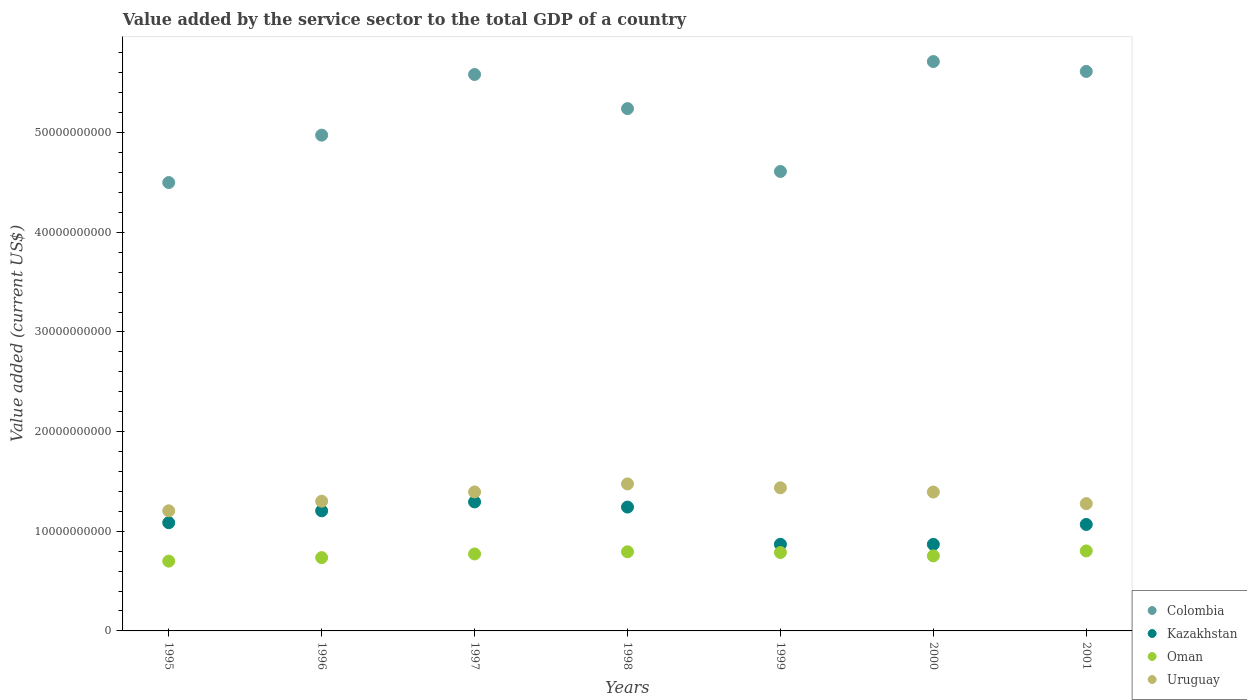Is the number of dotlines equal to the number of legend labels?
Offer a terse response. Yes. What is the value added by the service sector to the total GDP in Oman in 2001?
Offer a terse response. 8.03e+09. Across all years, what is the maximum value added by the service sector to the total GDP in Oman?
Your answer should be very brief. 8.03e+09. Across all years, what is the minimum value added by the service sector to the total GDP in Oman?
Your answer should be compact. 7.00e+09. What is the total value added by the service sector to the total GDP in Uruguay in the graph?
Your answer should be very brief. 9.48e+1. What is the difference between the value added by the service sector to the total GDP in Oman in 2000 and that in 2001?
Give a very brief answer. -4.96e+08. What is the difference between the value added by the service sector to the total GDP in Uruguay in 1995 and the value added by the service sector to the total GDP in Oman in 1999?
Your response must be concise. 4.19e+09. What is the average value added by the service sector to the total GDP in Colombia per year?
Give a very brief answer. 5.18e+1. In the year 1995, what is the difference between the value added by the service sector to the total GDP in Colombia and value added by the service sector to the total GDP in Oman?
Give a very brief answer. 3.80e+1. In how many years, is the value added by the service sector to the total GDP in Uruguay greater than 34000000000 US$?
Your response must be concise. 0. What is the ratio of the value added by the service sector to the total GDP in Oman in 1997 to that in 2001?
Provide a short and direct response. 0.96. What is the difference between the highest and the second highest value added by the service sector to the total GDP in Colombia?
Give a very brief answer. 9.92e+08. What is the difference between the highest and the lowest value added by the service sector to the total GDP in Uruguay?
Give a very brief answer. 2.70e+09. Is it the case that in every year, the sum of the value added by the service sector to the total GDP in Oman and value added by the service sector to the total GDP in Uruguay  is greater than the value added by the service sector to the total GDP in Kazakhstan?
Provide a succinct answer. Yes. Does the value added by the service sector to the total GDP in Kazakhstan monotonically increase over the years?
Ensure brevity in your answer.  No. Is the value added by the service sector to the total GDP in Uruguay strictly greater than the value added by the service sector to the total GDP in Kazakhstan over the years?
Keep it short and to the point. Yes. Is the value added by the service sector to the total GDP in Oman strictly less than the value added by the service sector to the total GDP in Uruguay over the years?
Keep it short and to the point. Yes. What is the difference between two consecutive major ticks on the Y-axis?
Make the answer very short. 1.00e+1. Does the graph contain grids?
Provide a short and direct response. No. Where does the legend appear in the graph?
Provide a short and direct response. Bottom right. How are the legend labels stacked?
Offer a terse response. Vertical. What is the title of the graph?
Make the answer very short. Value added by the service sector to the total GDP of a country. What is the label or title of the Y-axis?
Offer a very short reply. Value added (current US$). What is the Value added (current US$) of Colombia in 1995?
Your answer should be very brief. 4.50e+1. What is the Value added (current US$) of Kazakhstan in 1995?
Provide a short and direct response. 1.09e+1. What is the Value added (current US$) in Oman in 1995?
Your response must be concise. 7.00e+09. What is the Value added (current US$) in Uruguay in 1995?
Your answer should be very brief. 1.21e+1. What is the Value added (current US$) of Colombia in 1996?
Your answer should be very brief. 4.97e+1. What is the Value added (current US$) in Kazakhstan in 1996?
Make the answer very short. 1.21e+1. What is the Value added (current US$) in Oman in 1996?
Provide a succinct answer. 7.35e+09. What is the Value added (current US$) in Uruguay in 1996?
Keep it short and to the point. 1.30e+1. What is the Value added (current US$) in Colombia in 1997?
Offer a very short reply. 5.58e+1. What is the Value added (current US$) of Kazakhstan in 1997?
Keep it short and to the point. 1.29e+1. What is the Value added (current US$) in Oman in 1997?
Make the answer very short. 7.72e+09. What is the Value added (current US$) in Uruguay in 1997?
Keep it short and to the point. 1.39e+1. What is the Value added (current US$) of Colombia in 1998?
Keep it short and to the point. 5.24e+1. What is the Value added (current US$) of Kazakhstan in 1998?
Your answer should be compact. 1.24e+1. What is the Value added (current US$) in Oman in 1998?
Your response must be concise. 7.94e+09. What is the Value added (current US$) of Uruguay in 1998?
Your answer should be very brief. 1.48e+1. What is the Value added (current US$) of Colombia in 1999?
Your response must be concise. 4.61e+1. What is the Value added (current US$) in Kazakhstan in 1999?
Make the answer very short. 8.69e+09. What is the Value added (current US$) of Oman in 1999?
Keep it short and to the point. 7.87e+09. What is the Value added (current US$) of Uruguay in 1999?
Your answer should be compact. 1.44e+1. What is the Value added (current US$) of Colombia in 2000?
Your answer should be compact. 5.71e+1. What is the Value added (current US$) of Kazakhstan in 2000?
Provide a succinct answer. 8.68e+09. What is the Value added (current US$) in Oman in 2000?
Your answer should be compact. 7.53e+09. What is the Value added (current US$) of Uruguay in 2000?
Provide a succinct answer. 1.39e+1. What is the Value added (current US$) in Colombia in 2001?
Give a very brief answer. 5.61e+1. What is the Value added (current US$) in Kazakhstan in 2001?
Your answer should be very brief. 1.07e+1. What is the Value added (current US$) in Oman in 2001?
Make the answer very short. 8.03e+09. What is the Value added (current US$) of Uruguay in 2001?
Offer a terse response. 1.28e+1. Across all years, what is the maximum Value added (current US$) of Colombia?
Ensure brevity in your answer.  5.71e+1. Across all years, what is the maximum Value added (current US$) of Kazakhstan?
Your response must be concise. 1.29e+1. Across all years, what is the maximum Value added (current US$) of Oman?
Offer a very short reply. 8.03e+09. Across all years, what is the maximum Value added (current US$) in Uruguay?
Provide a short and direct response. 1.48e+1. Across all years, what is the minimum Value added (current US$) in Colombia?
Give a very brief answer. 4.50e+1. Across all years, what is the minimum Value added (current US$) of Kazakhstan?
Your answer should be compact. 8.68e+09. Across all years, what is the minimum Value added (current US$) of Oman?
Provide a succinct answer. 7.00e+09. Across all years, what is the minimum Value added (current US$) of Uruguay?
Ensure brevity in your answer.  1.21e+1. What is the total Value added (current US$) in Colombia in the graph?
Provide a succinct answer. 3.62e+11. What is the total Value added (current US$) of Kazakhstan in the graph?
Offer a terse response. 7.63e+1. What is the total Value added (current US$) of Oman in the graph?
Provide a succinct answer. 5.34e+1. What is the total Value added (current US$) of Uruguay in the graph?
Your answer should be very brief. 9.48e+1. What is the difference between the Value added (current US$) of Colombia in 1995 and that in 1996?
Ensure brevity in your answer.  -4.75e+09. What is the difference between the Value added (current US$) of Kazakhstan in 1995 and that in 1996?
Make the answer very short. -1.19e+09. What is the difference between the Value added (current US$) of Oman in 1995 and that in 1996?
Keep it short and to the point. -3.50e+08. What is the difference between the Value added (current US$) in Uruguay in 1995 and that in 1996?
Give a very brief answer. -9.60e+08. What is the difference between the Value added (current US$) in Colombia in 1995 and that in 1997?
Your answer should be compact. -1.08e+1. What is the difference between the Value added (current US$) of Kazakhstan in 1995 and that in 1997?
Provide a succinct answer. -2.08e+09. What is the difference between the Value added (current US$) in Oman in 1995 and that in 1997?
Provide a short and direct response. -7.19e+08. What is the difference between the Value added (current US$) of Uruguay in 1995 and that in 1997?
Give a very brief answer. -1.89e+09. What is the difference between the Value added (current US$) of Colombia in 1995 and that in 1998?
Provide a succinct answer. -7.42e+09. What is the difference between the Value added (current US$) in Kazakhstan in 1995 and that in 1998?
Keep it short and to the point. -1.57e+09. What is the difference between the Value added (current US$) of Oman in 1995 and that in 1998?
Your answer should be compact. -9.37e+08. What is the difference between the Value added (current US$) in Uruguay in 1995 and that in 1998?
Your answer should be very brief. -2.70e+09. What is the difference between the Value added (current US$) of Colombia in 1995 and that in 1999?
Give a very brief answer. -1.11e+09. What is the difference between the Value added (current US$) in Kazakhstan in 1995 and that in 1999?
Your response must be concise. 2.17e+09. What is the difference between the Value added (current US$) in Oman in 1995 and that in 1999?
Your answer should be compact. -8.64e+08. What is the difference between the Value added (current US$) in Uruguay in 1995 and that in 1999?
Make the answer very short. -2.31e+09. What is the difference between the Value added (current US$) in Colombia in 1995 and that in 2000?
Make the answer very short. -1.21e+1. What is the difference between the Value added (current US$) of Kazakhstan in 1995 and that in 2000?
Make the answer very short. 2.18e+09. What is the difference between the Value added (current US$) in Oman in 1995 and that in 2000?
Your answer should be compact. -5.27e+08. What is the difference between the Value added (current US$) in Uruguay in 1995 and that in 2000?
Your answer should be very brief. -1.88e+09. What is the difference between the Value added (current US$) of Colombia in 1995 and that in 2001?
Give a very brief answer. -1.11e+1. What is the difference between the Value added (current US$) of Kazakhstan in 1995 and that in 2001?
Provide a short and direct response. 1.77e+08. What is the difference between the Value added (current US$) of Oman in 1995 and that in 2001?
Provide a succinct answer. -1.02e+09. What is the difference between the Value added (current US$) of Uruguay in 1995 and that in 2001?
Make the answer very short. -7.18e+08. What is the difference between the Value added (current US$) in Colombia in 1996 and that in 1997?
Give a very brief answer. -6.09e+09. What is the difference between the Value added (current US$) in Kazakhstan in 1996 and that in 1997?
Provide a short and direct response. -8.92e+08. What is the difference between the Value added (current US$) in Oman in 1996 and that in 1997?
Offer a very short reply. -3.69e+08. What is the difference between the Value added (current US$) of Uruguay in 1996 and that in 1997?
Your response must be concise. -9.29e+08. What is the difference between the Value added (current US$) of Colombia in 1996 and that in 1998?
Your answer should be very brief. -2.66e+09. What is the difference between the Value added (current US$) of Kazakhstan in 1996 and that in 1998?
Make the answer very short. -3.76e+08. What is the difference between the Value added (current US$) in Oman in 1996 and that in 1998?
Offer a very short reply. -5.87e+08. What is the difference between the Value added (current US$) of Uruguay in 1996 and that in 1998?
Provide a short and direct response. -1.74e+09. What is the difference between the Value added (current US$) in Colombia in 1996 and that in 1999?
Your response must be concise. 3.64e+09. What is the difference between the Value added (current US$) in Kazakhstan in 1996 and that in 1999?
Give a very brief answer. 3.36e+09. What is the difference between the Value added (current US$) of Oman in 1996 and that in 1999?
Make the answer very short. -5.14e+08. What is the difference between the Value added (current US$) of Uruguay in 1996 and that in 1999?
Ensure brevity in your answer.  -1.35e+09. What is the difference between the Value added (current US$) of Colombia in 1996 and that in 2000?
Your answer should be very brief. -7.39e+09. What is the difference between the Value added (current US$) in Kazakhstan in 1996 and that in 2000?
Give a very brief answer. 3.37e+09. What is the difference between the Value added (current US$) of Oman in 1996 and that in 2000?
Ensure brevity in your answer.  -1.77e+08. What is the difference between the Value added (current US$) of Uruguay in 1996 and that in 2000?
Your response must be concise. -9.21e+08. What is the difference between the Value added (current US$) in Colombia in 1996 and that in 2001?
Your response must be concise. -6.39e+09. What is the difference between the Value added (current US$) of Kazakhstan in 1996 and that in 2001?
Provide a short and direct response. 1.37e+09. What is the difference between the Value added (current US$) in Oman in 1996 and that in 2001?
Give a very brief answer. -6.74e+08. What is the difference between the Value added (current US$) in Uruguay in 1996 and that in 2001?
Your answer should be compact. 2.42e+08. What is the difference between the Value added (current US$) in Colombia in 1997 and that in 1998?
Provide a succinct answer. 3.43e+09. What is the difference between the Value added (current US$) of Kazakhstan in 1997 and that in 1998?
Offer a terse response. 5.16e+08. What is the difference between the Value added (current US$) of Oman in 1997 and that in 1998?
Provide a short and direct response. -2.18e+08. What is the difference between the Value added (current US$) of Uruguay in 1997 and that in 1998?
Give a very brief answer. -8.08e+08. What is the difference between the Value added (current US$) in Colombia in 1997 and that in 1999?
Provide a succinct answer. 9.73e+09. What is the difference between the Value added (current US$) in Kazakhstan in 1997 and that in 1999?
Keep it short and to the point. 4.25e+09. What is the difference between the Value added (current US$) in Oman in 1997 and that in 1999?
Provide a succinct answer. -1.46e+08. What is the difference between the Value added (current US$) of Uruguay in 1997 and that in 1999?
Provide a succinct answer. -4.17e+08. What is the difference between the Value added (current US$) in Colombia in 1997 and that in 2000?
Provide a short and direct response. -1.30e+09. What is the difference between the Value added (current US$) in Kazakhstan in 1997 and that in 2000?
Your answer should be compact. 4.26e+09. What is the difference between the Value added (current US$) in Oman in 1997 and that in 2000?
Make the answer very short. 1.92e+08. What is the difference between the Value added (current US$) in Uruguay in 1997 and that in 2000?
Your answer should be very brief. 8.73e+06. What is the difference between the Value added (current US$) in Colombia in 1997 and that in 2001?
Offer a very short reply. -3.06e+08. What is the difference between the Value added (current US$) in Kazakhstan in 1997 and that in 2001?
Your answer should be compact. 2.26e+09. What is the difference between the Value added (current US$) in Oman in 1997 and that in 2001?
Your response must be concise. -3.05e+08. What is the difference between the Value added (current US$) of Uruguay in 1997 and that in 2001?
Offer a terse response. 1.17e+09. What is the difference between the Value added (current US$) of Colombia in 1998 and that in 1999?
Offer a terse response. 6.31e+09. What is the difference between the Value added (current US$) in Kazakhstan in 1998 and that in 1999?
Offer a terse response. 3.74e+09. What is the difference between the Value added (current US$) of Oman in 1998 and that in 1999?
Give a very brief answer. 7.28e+07. What is the difference between the Value added (current US$) of Uruguay in 1998 and that in 1999?
Your answer should be compact. 3.91e+08. What is the difference between the Value added (current US$) in Colombia in 1998 and that in 2000?
Provide a short and direct response. -4.72e+09. What is the difference between the Value added (current US$) in Kazakhstan in 1998 and that in 2000?
Ensure brevity in your answer.  3.74e+09. What is the difference between the Value added (current US$) in Oman in 1998 and that in 2000?
Offer a very short reply. 4.10e+08. What is the difference between the Value added (current US$) in Uruguay in 1998 and that in 2000?
Give a very brief answer. 8.17e+08. What is the difference between the Value added (current US$) of Colombia in 1998 and that in 2001?
Your answer should be compact. -3.73e+09. What is the difference between the Value added (current US$) of Kazakhstan in 1998 and that in 2001?
Keep it short and to the point. 1.74e+09. What is the difference between the Value added (current US$) of Oman in 1998 and that in 2001?
Provide a short and direct response. -8.65e+07. What is the difference between the Value added (current US$) of Uruguay in 1998 and that in 2001?
Make the answer very short. 1.98e+09. What is the difference between the Value added (current US$) of Colombia in 1999 and that in 2000?
Keep it short and to the point. -1.10e+1. What is the difference between the Value added (current US$) of Kazakhstan in 1999 and that in 2000?
Your answer should be very brief. 7.84e+06. What is the difference between the Value added (current US$) of Oman in 1999 and that in 2000?
Make the answer very short. 3.37e+08. What is the difference between the Value added (current US$) in Uruguay in 1999 and that in 2000?
Ensure brevity in your answer.  4.26e+08. What is the difference between the Value added (current US$) of Colombia in 1999 and that in 2001?
Ensure brevity in your answer.  -1.00e+1. What is the difference between the Value added (current US$) of Kazakhstan in 1999 and that in 2001?
Ensure brevity in your answer.  -1.99e+09. What is the difference between the Value added (current US$) of Oman in 1999 and that in 2001?
Offer a terse response. -1.59e+08. What is the difference between the Value added (current US$) of Uruguay in 1999 and that in 2001?
Give a very brief answer. 1.59e+09. What is the difference between the Value added (current US$) in Colombia in 2000 and that in 2001?
Make the answer very short. 9.92e+08. What is the difference between the Value added (current US$) of Kazakhstan in 2000 and that in 2001?
Give a very brief answer. -2.00e+09. What is the difference between the Value added (current US$) of Oman in 2000 and that in 2001?
Keep it short and to the point. -4.96e+08. What is the difference between the Value added (current US$) of Uruguay in 2000 and that in 2001?
Offer a terse response. 1.16e+09. What is the difference between the Value added (current US$) of Colombia in 1995 and the Value added (current US$) of Kazakhstan in 1996?
Give a very brief answer. 3.29e+1. What is the difference between the Value added (current US$) of Colombia in 1995 and the Value added (current US$) of Oman in 1996?
Provide a succinct answer. 3.76e+1. What is the difference between the Value added (current US$) in Colombia in 1995 and the Value added (current US$) in Uruguay in 1996?
Make the answer very short. 3.20e+1. What is the difference between the Value added (current US$) in Kazakhstan in 1995 and the Value added (current US$) in Oman in 1996?
Your response must be concise. 3.51e+09. What is the difference between the Value added (current US$) in Kazakhstan in 1995 and the Value added (current US$) in Uruguay in 1996?
Your response must be concise. -2.15e+09. What is the difference between the Value added (current US$) in Oman in 1995 and the Value added (current US$) in Uruguay in 1996?
Provide a short and direct response. -6.01e+09. What is the difference between the Value added (current US$) of Colombia in 1995 and the Value added (current US$) of Kazakhstan in 1997?
Make the answer very short. 3.20e+1. What is the difference between the Value added (current US$) in Colombia in 1995 and the Value added (current US$) in Oman in 1997?
Your answer should be very brief. 3.73e+1. What is the difference between the Value added (current US$) in Colombia in 1995 and the Value added (current US$) in Uruguay in 1997?
Provide a succinct answer. 3.10e+1. What is the difference between the Value added (current US$) in Kazakhstan in 1995 and the Value added (current US$) in Oman in 1997?
Keep it short and to the point. 3.14e+09. What is the difference between the Value added (current US$) in Kazakhstan in 1995 and the Value added (current US$) in Uruguay in 1997?
Give a very brief answer. -3.08e+09. What is the difference between the Value added (current US$) of Oman in 1995 and the Value added (current US$) of Uruguay in 1997?
Your response must be concise. -6.94e+09. What is the difference between the Value added (current US$) in Colombia in 1995 and the Value added (current US$) in Kazakhstan in 1998?
Your answer should be very brief. 3.26e+1. What is the difference between the Value added (current US$) in Colombia in 1995 and the Value added (current US$) in Oman in 1998?
Make the answer very short. 3.70e+1. What is the difference between the Value added (current US$) in Colombia in 1995 and the Value added (current US$) in Uruguay in 1998?
Ensure brevity in your answer.  3.02e+1. What is the difference between the Value added (current US$) in Kazakhstan in 1995 and the Value added (current US$) in Oman in 1998?
Offer a terse response. 2.92e+09. What is the difference between the Value added (current US$) in Kazakhstan in 1995 and the Value added (current US$) in Uruguay in 1998?
Your response must be concise. -3.89e+09. What is the difference between the Value added (current US$) in Oman in 1995 and the Value added (current US$) in Uruguay in 1998?
Provide a short and direct response. -7.75e+09. What is the difference between the Value added (current US$) of Colombia in 1995 and the Value added (current US$) of Kazakhstan in 1999?
Give a very brief answer. 3.63e+1. What is the difference between the Value added (current US$) in Colombia in 1995 and the Value added (current US$) in Oman in 1999?
Provide a succinct answer. 3.71e+1. What is the difference between the Value added (current US$) in Colombia in 1995 and the Value added (current US$) in Uruguay in 1999?
Make the answer very short. 3.06e+1. What is the difference between the Value added (current US$) in Kazakhstan in 1995 and the Value added (current US$) in Oman in 1999?
Keep it short and to the point. 2.99e+09. What is the difference between the Value added (current US$) of Kazakhstan in 1995 and the Value added (current US$) of Uruguay in 1999?
Provide a succinct answer. -3.50e+09. What is the difference between the Value added (current US$) in Oman in 1995 and the Value added (current US$) in Uruguay in 1999?
Give a very brief answer. -7.36e+09. What is the difference between the Value added (current US$) of Colombia in 1995 and the Value added (current US$) of Kazakhstan in 2000?
Your answer should be very brief. 3.63e+1. What is the difference between the Value added (current US$) in Colombia in 1995 and the Value added (current US$) in Oman in 2000?
Make the answer very short. 3.75e+1. What is the difference between the Value added (current US$) in Colombia in 1995 and the Value added (current US$) in Uruguay in 2000?
Provide a succinct answer. 3.11e+1. What is the difference between the Value added (current US$) in Kazakhstan in 1995 and the Value added (current US$) in Oman in 2000?
Provide a succinct answer. 3.33e+09. What is the difference between the Value added (current US$) of Kazakhstan in 1995 and the Value added (current US$) of Uruguay in 2000?
Your answer should be very brief. -3.08e+09. What is the difference between the Value added (current US$) in Oman in 1995 and the Value added (current US$) in Uruguay in 2000?
Your answer should be very brief. -6.93e+09. What is the difference between the Value added (current US$) of Colombia in 1995 and the Value added (current US$) of Kazakhstan in 2001?
Your answer should be compact. 3.43e+1. What is the difference between the Value added (current US$) of Colombia in 1995 and the Value added (current US$) of Oman in 2001?
Give a very brief answer. 3.70e+1. What is the difference between the Value added (current US$) in Colombia in 1995 and the Value added (current US$) in Uruguay in 2001?
Offer a very short reply. 3.22e+1. What is the difference between the Value added (current US$) in Kazakhstan in 1995 and the Value added (current US$) in Oman in 2001?
Offer a terse response. 2.83e+09. What is the difference between the Value added (current US$) in Kazakhstan in 1995 and the Value added (current US$) in Uruguay in 2001?
Make the answer very short. -1.91e+09. What is the difference between the Value added (current US$) in Oman in 1995 and the Value added (current US$) in Uruguay in 2001?
Provide a succinct answer. -5.77e+09. What is the difference between the Value added (current US$) of Colombia in 1996 and the Value added (current US$) of Kazakhstan in 1997?
Your response must be concise. 3.68e+1. What is the difference between the Value added (current US$) in Colombia in 1996 and the Value added (current US$) in Oman in 1997?
Keep it short and to the point. 4.20e+1. What is the difference between the Value added (current US$) of Colombia in 1996 and the Value added (current US$) of Uruguay in 1997?
Offer a very short reply. 3.58e+1. What is the difference between the Value added (current US$) of Kazakhstan in 1996 and the Value added (current US$) of Oman in 1997?
Offer a terse response. 4.33e+09. What is the difference between the Value added (current US$) in Kazakhstan in 1996 and the Value added (current US$) in Uruguay in 1997?
Keep it short and to the point. -1.89e+09. What is the difference between the Value added (current US$) in Oman in 1996 and the Value added (current US$) in Uruguay in 1997?
Your response must be concise. -6.59e+09. What is the difference between the Value added (current US$) of Colombia in 1996 and the Value added (current US$) of Kazakhstan in 1998?
Your answer should be compact. 3.73e+1. What is the difference between the Value added (current US$) of Colombia in 1996 and the Value added (current US$) of Oman in 1998?
Your answer should be compact. 4.18e+1. What is the difference between the Value added (current US$) in Colombia in 1996 and the Value added (current US$) in Uruguay in 1998?
Give a very brief answer. 3.50e+1. What is the difference between the Value added (current US$) of Kazakhstan in 1996 and the Value added (current US$) of Oman in 1998?
Provide a succinct answer. 4.11e+09. What is the difference between the Value added (current US$) in Kazakhstan in 1996 and the Value added (current US$) in Uruguay in 1998?
Provide a short and direct response. -2.70e+09. What is the difference between the Value added (current US$) in Oman in 1996 and the Value added (current US$) in Uruguay in 1998?
Make the answer very short. -7.40e+09. What is the difference between the Value added (current US$) in Colombia in 1996 and the Value added (current US$) in Kazakhstan in 1999?
Your answer should be compact. 4.11e+1. What is the difference between the Value added (current US$) in Colombia in 1996 and the Value added (current US$) in Oman in 1999?
Provide a succinct answer. 4.19e+1. What is the difference between the Value added (current US$) in Colombia in 1996 and the Value added (current US$) in Uruguay in 1999?
Make the answer very short. 3.54e+1. What is the difference between the Value added (current US$) in Kazakhstan in 1996 and the Value added (current US$) in Oman in 1999?
Ensure brevity in your answer.  4.18e+09. What is the difference between the Value added (current US$) of Kazakhstan in 1996 and the Value added (current US$) of Uruguay in 1999?
Your response must be concise. -2.31e+09. What is the difference between the Value added (current US$) of Oman in 1996 and the Value added (current US$) of Uruguay in 1999?
Your answer should be very brief. -7.01e+09. What is the difference between the Value added (current US$) in Colombia in 1996 and the Value added (current US$) in Kazakhstan in 2000?
Make the answer very short. 4.11e+1. What is the difference between the Value added (current US$) in Colombia in 1996 and the Value added (current US$) in Oman in 2000?
Ensure brevity in your answer.  4.22e+1. What is the difference between the Value added (current US$) of Colombia in 1996 and the Value added (current US$) of Uruguay in 2000?
Ensure brevity in your answer.  3.58e+1. What is the difference between the Value added (current US$) of Kazakhstan in 1996 and the Value added (current US$) of Oman in 2000?
Your answer should be compact. 4.52e+09. What is the difference between the Value added (current US$) in Kazakhstan in 1996 and the Value added (current US$) in Uruguay in 2000?
Your answer should be very brief. -1.88e+09. What is the difference between the Value added (current US$) in Oman in 1996 and the Value added (current US$) in Uruguay in 2000?
Your response must be concise. -6.58e+09. What is the difference between the Value added (current US$) of Colombia in 1996 and the Value added (current US$) of Kazakhstan in 2001?
Your answer should be compact. 3.91e+1. What is the difference between the Value added (current US$) in Colombia in 1996 and the Value added (current US$) in Oman in 2001?
Give a very brief answer. 4.17e+1. What is the difference between the Value added (current US$) in Colombia in 1996 and the Value added (current US$) in Uruguay in 2001?
Ensure brevity in your answer.  3.70e+1. What is the difference between the Value added (current US$) in Kazakhstan in 1996 and the Value added (current US$) in Oman in 2001?
Your answer should be compact. 4.02e+09. What is the difference between the Value added (current US$) in Kazakhstan in 1996 and the Value added (current US$) in Uruguay in 2001?
Offer a terse response. -7.22e+08. What is the difference between the Value added (current US$) in Oman in 1996 and the Value added (current US$) in Uruguay in 2001?
Offer a very short reply. -5.42e+09. What is the difference between the Value added (current US$) in Colombia in 1997 and the Value added (current US$) in Kazakhstan in 1998?
Make the answer very short. 4.34e+1. What is the difference between the Value added (current US$) in Colombia in 1997 and the Value added (current US$) in Oman in 1998?
Offer a terse response. 4.79e+1. What is the difference between the Value added (current US$) of Colombia in 1997 and the Value added (current US$) of Uruguay in 1998?
Offer a terse response. 4.11e+1. What is the difference between the Value added (current US$) in Kazakhstan in 1997 and the Value added (current US$) in Oman in 1998?
Keep it short and to the point. 5.00e+09. What is the difference between the Value added (current US$) of Kazakhstan in 1997 and the Value added (current US$) of Uruguay in 1998?
Offer a terse response. -1.81e+09. What is the difference between the Value added (current US$) in Oman in 1997 and the Value added (current US$) in Uruguay in 1998?
Ensure brevity in your answer.  -7.03e+09. What is the difference between the Value added (current US$) of Colombia in 1997 and the Value added (current US$) of Kazakhstan in 1999?
Give a very brief answer. 4.71e+1. What is the difference between the Value added (current US$) in Colombia in 1997 and the Value added (current US$) in Oman in 1999?
Give a very brief answer. 4.80e+1. What is the difference between the Value added (current US$) in Colombia in 1997 and the Value added (current US$) in Uruguay in 1999?
Your response must be concise. 4.15e+1. What is the difference between the Value added (current US$) in Kazakhstan in 1997 and the Value added (current US$) in Oman in 1999?
Provide a short and direct response. 5.07e+09. What is the difference between the Value added (current US$) of Kazakhstan in 1997 and the Value added (current US$) of Uruguay in 1999?
Ensure brevity in your answer.  -1.42e+09. What is the difference between the Value added (current US$) in Oman in 1997 and the Value added (current US$) in Uruguay in 1999?
Your response must be concise. -6.64e+09. What is the difference between the Value added (current US$) of Colombia in 1997 and the Value added (current US$) of Kazakhstan in 2000?
Offer a terse response. 4.71e+1. What is the difference between the Value added (current US$) in Colombia in 1997 and the Value added (current US$) in Oman in 2000?
Keep it short and to the point. 4.83e+1. What is the difference between the Value added (current US$) of Colombia in 1997 and the Value added (current US$) of Uruguay in 2000?
Keep it short and to the point. 4.19e+1. What is the difference between the Value added (current US$) in Kazakhstan in 1997 and the Value added (current US$) in Oman in 2000?
Provide a short and direct response. 5.41e+09. What is the difference between the Value added (current US$) in Kazakhstan in 1997 and the Value added (current US$) in Uruguay in 2000?
Your answer should be compact. -9.93e+08. What is the difference between the Value added (current US$) of Oman in 1997 and the Value added (current US$) of Uruguay in 2000?
Make the answer very short. -6.21e+09. What is the difference between the Value added (current US$) of Colombia in 1997 and the Value added (current US$) of Kazakhstan in 2001?
Give a very brief answer. 4.51e+1. What is the difference between the Value added (current US$) in Colombia in 1997 and the Value added (current US$) in Oman in 2001?
Offer a very short reply. 4.78e+1. What is the difference between the Value added (current US$) in Colombia in 1997 and the Value added (current US$) in Uruguay in 2001?
Ensure brevity in your answer.  4.31e+1. What is the difference between the Value added (current US$) of Kazakhstan in 1997 and the Value added (current US$) of Oman in 2001?
Your answer should be compact. 4.92e+09. What is the difference between the Value added (current US$) in Kazakhstan in 1997 and the Value added (current US$) in Uruguay in 2001?
Ensure brevity in your answer.  1.70e+08. What is the difference between the Value added (current US$) in Oman in 1997 and the Value added (current US$) in Uruguay in 2001?
Your answer should be compact. -5.05e+09. What is the difference between the Value added (current US$) of Colombia in 1998 and the Value added (current US$) of Kazakhstan in 1999?
Keep it short and to the point. 4.37e+1. What is the difference between the Value added (current US$) of Colombia in 1998 and the Value added (current US$) of Oman in 1999?
Keep it short and to the point. 4.45e+1. What is the difference between the Value added (current US$) of Colombia in 1998 and the Value added (current US$) of Uruguay in 1999?
Provide a succinct answer. 3.80e+1. What is the difference between the Value added (current US$) in Kazakhstan in 1998 and the Value added (current US$) in Oman in 1999?
Your answer should be very brief. 4.56e+09. What is the difference between the Value added (current US$) in Kazakhstan in 1998 and the Value added (current US$) in Uruguay in 1999?
Make the answer very short. -1.93e+09. What is the difference between the Value added (current US$) in Oman in 1998 and the Value added (current US$) in Uruguay in 1999?
Your answer should be compact. -6.42e+09. What is the difference between the Value added (current US$) in Colombia in 1998 and the Value added (current US$) in Kazakhstan in 2000?
Keep it short and to the point. 4.37e+1. What is the difference between the Value added (current US$) of Colombia in 1998 and the Value added (current US$) of Oman in 2000?
Provide a short and direct response. 4.49e+1. What is the difference between the Value added (current US$) in Colombia in 1998 and the Value added (current US$) in Uruguay in 2000?
Offer a very short reply. 3.85e+1. What is the difference between the Value added (current US$) of Kazakhstan in 1998 and the Value added (current US$) of Oman in 2000?
Make the answer very short. 4.90e+09. What is the difference between the Value added (current US$) in Kazakhstan in 1998 and the Value added (current US$) in Uruguay in 2000?
Your answer should be compact. -1.51e+09. What is the difference between the Value added (current US$) in Oman in 1998 and the Value added (current US$) in Uruguay in 2000?
Provide a short and direct response. -6.00e+09. What is the difference between the Value added (current US$) in Colombia in 1998 and the Value added (current US$) in Kazakhstan in 2001?
Provide a short and direct response. 4.17e+1. What is the difference between the Value added (current US$) of Colombia in 1998 and the Value added (current US$) of Oman in 2001?
Your answer should be compact. 4.44e+1. What is the difference between the Value added (current US$) in Colombia in 1998 and the Value added (current US$) in Uruguay in 2001?
Keep it short and to the point. 3.96e+1. What is the difference between the Value added (current US$) in Kazakhstan in 1998 and the Value added (current US$) in Oman in 2001?
Offer a very short reply. 4.40e+09. What is the difference between the Value added (current US$) in Kazakhstan in 1998 and the Value added (current US$) in Uruguay in 2001?
Your answer should be very brief. -3.46e+08. What is the difference between the Value added (current US$) in Oman in 1998 and the Value added (current US$) in Uruguay in 2001?
Your answer should be compact. -4.83e+09. What is the difference between the Value added (current US$) in Colombia in 1999 and the Value added (current US$) in Kazakhstan in 2000?
Provide a succinct answer. 3.74e+1. What is the difference between the Value added (current US$) in Colombia in 1999 and the Value added (current US$) in Oman in 2000?
Keep it short and to the point. 3.86e+1. What is the difference between the Value added (current US$) of Colombia in 1999 and the Value added (current US$) of Uruguay in 2000?
Give a very brief answer. 3.22e+1. What is the difference between the Value added (current US$) of Kazakhstan in 1999 and the Value added (current US$) of Oman in 2000?
Ensure brevity in your answer.  1.16e+09. What is the difference between the Value added (current US$) in Kazakhstan in 1999 and the Value added (current US$) in Uruguay in 2000?
Offer a very short reply. -5.24e+09. What is the difference between the Value added (current US$) in Oman in 1999 and the Value added (current US$) in Uruguay in 2000?
Provide a short and direct response. -6.07e+09. What is the difference between the Value added (current US$) of Colombia in 1999 and the Value added (current US$) of Kazakhstan in 2001?
Keep it short and to the point. 3.54e+1. What is the difference between the Value added (current US$) in Colombia in 1999 and the Value added (current US$) in Oman in 2001?
Your response must be concise. 3.81e+1. What is the difference between the Value added (current US$) of Colombia in 1999 and the Value added (current US$) of Uruguay in 2001?
Provide a short and direct response. 3.33e+1. What is the difference between the Value added (current US$) of Kazakhstan in 1999 and the Value added (current US$) of Oman in 2001?
Offer a terse response. 6.65e+08. What is the difference between the Value added (current US$) in Kazakhstan in 1999 and the Value added (current US$) in Uruguay in 2001?
Give a very brief answer. -4.08e+09. What is the difference between the Value added (current US$) of Oman in 1999 and the Value added (current US$) of Uruguay in 2001?
Give a very brief answer. -4.91e+09. What is the difference between the Value added (current US$) in Colombia in 2000 and the Value added (current US$) in Kazakhstan in 2001?
Keep it short and to the point. 4.64e+1. What is the difference between the Value added (current US$) of Colombia in 2000 and the Value added (current US$) of Oman in 2001?
Offer a terse response. 4.91e+1. What is the difference between the Value added (current US$) in Colombia in 2000 and the Value added (current US$) in Uruguay in 2001?
Provide a succinct answer. 4.44e+1. What is the difference between the Value added (current US$) of Kazakhstan in 2000 and the Value added (current US$) of Oman in 2001?
Offer a very short reply. 6.57e+08. What is the difference between the Value added (current US$) of Kazakhstan in 2000 and the Value added (current US$) of Uruguay in 2001?
Offer a very short reply. -4.09e+09. What is the difference between the Value added (current US$) in Oman in 2000 and the Value added (current US$) in Uruguay in 2001?
Your answer should be very brief. -5.24e+09. What is the average Value added (current US$) in Colombia per year?
Give a very brief answer. 5.18e+1. What is the average Value added (current US$) of Kazakhstan per year?
Your answer should be very brief. 1.09e+1. What is the average Value added (current US$) of Oman per year?
Provide a succinct answer. 7.63e+09. What is the average Value added (current US$) of Uruguay per year?
Offer a terse response. 1.35e+1. In the year 1995, what is the difference between the Value added (current US$) of Colombia and Value added (current US$) of Kazakhstan?
Make the answer very short. 3.41e+1. In the year 1995, what is the difference between the Value added (current US$) in Colombia and Value added (current US$) in Oman?
Make the answer very short. 3.80e+1. In the year 1995, what is the difference between the Value added (current US$) of Colombia and Value added (current US$) of Uruguay?
Provide a short and direct response. 3.29e+1. In the year 1995, what is the difference between the Value added (current US$) in Kazakhstan and Value added (current US$) in Oman?
Give a very brief answer. 3.86e+09. In the year 1995, what is the difference between the Value added (current US$) in Kazakhstan and Value added (current US$) in Uruguay?
Provide a succinct answer. -1.19e+09. In the year 1995, what is the difference between the Value added (current US$) of Oman and Value added (current US$) of Uruguay?
Your response must be concise. -5.05e+09. In the year 1996, what is the difference between the Value added (current US$) of Colombia and Value added (current US$) of Kazakhstan?
Make the answer very short. 3.77e+1. In the year 1996, what is the difference between the Value added (current US$) of Colombia and Value added (current US$) of Oman?
Provide a short and direct response. 4.24e+1. In the year 1996, what is the difference between the Value added (current US$) in Colombia and Value added (current US$) in Uruguay?
Provide a succinct answer. 3.67e+1. In the year 1996, what is the difference between the Value added (current US$) of Kazakhstan and Value added (current US$) of Oman?
Provide a short and direct response. 4.70e+09. In the year 1996, what is the difference between the Value added (current US$) in Kazakhstan and Value added (current US$) in Uruguay?
Your answer should be very brief. -9.64e+08. In the year 1996, what is the difference between the Value added (current US$) in Oman and Value added (current US$) in Uruguay?
Ensure brevity in your answer.  -5.66e+09. In the year 1997, what is the difference between the Value added (current US$) of Colombia and Value added (current US$) of Kazakhstan?
Offer a terse response. 4.29e+1. In the year 1997, what is the difference between the Value added (current US$) in Colombia and Value added (current US$) in Oman?
Offer a very short reply. 4.81e+1. In the year 1997, what is the difference between the Value added (current US$) of Colombia and Value added (current US$) of Uruguay?
Provide a succinct answer. 4.19e+1. In the year 1997, what is the difference between the Value added (current US$) in Kazakhstan and Value added (current US$) in Oman?
Ensure brevity in your answer.  5.22e+09. In the year 1997, what is the difference between the Value added (current US$) of Kazakhstan and Value added (current US$) of Uruguay?
Offer a terse response. -1.00e+09. In the year 1997, what is the difference between the Value added (current US$) of Oman and Value added (current US$) of Uruguay?
Offer a very short reply. -6.22e+09. In the year 1998, what is the difference between the Value added (current US$) of Colombia and Value added (current US$) of Kazakhstan?
Give a very brief answer. 4.00e+1. In the year 1998, what is the difference between the Value added (current US$) in Colombia and Value added (current US$) in Oman?
Your response must be concise. 4.45e+1. In the year 1998, what is the difference between the Value added (current US$) in Colombia and Value added (current US$) in Uruguay?
Keep it short and to the point. 3.77e+1. In the year 1998, what is the difference between the Value added (current US$) of Kazakhstan and Value added (current US$) of Oman?
Offer a very short reply. 4.49e+09. In the year 1998, what is the difference between the Value added (current US$) in Kazakhstan and Value added (current US$) in Uruguay?
Your response must be concise. -2.33e+09. In the year 1998, what is the difference between the Value added (current US$) in Oman and Value added (current US$) in Uruguay?
Offer a terse response. -6.81e+09. In the year 1999, what is the difference between the Value added (current US$) in Colombia and Value added (current US$) in Kazakhstan?
Make the answer very short. 3.74e+1. In the year 1999, what is the difference between the Value added (current US$) in Colombia and Value added (current US$) in Oman?
Give a very brief answer. 3.82e+1. In the year 1999, what is the difference between the Value added (current US$) in Colombia and Value added (current US$) in Uruguay?
Offer a terse response. 3.17e+1. In the year 1999, what is the difference between the Value added (current US$) in Kazakhstan and Value added (current US$) in Oman?
Offer a terse response. 8.24e+08. In the year 1999, what is the difference between the Value added (current US$) in Kazakhstan and Value added (current US$) in Uruguay?
Make the answer very short. -5.67e+09. In the year 1999, what is the difference between the Value added (current US$) of Oman and Value added (current US$) of Uruguay?
Make the answer very short. -6.49e+09. In the year 2000, what is the difference between the Value added (current US$) in Colombia and Value added (current US$) in Kazakhstan?
Your answer should be very brief. 4.84e+1. In the year 2000, what is the difference between the Value added (current US$) in Colombia and Value added (current US$) in Oman?
Offer a terse response. 4.96e+1. In the year 2000, what is the difference between the Value added (current US$) of Colombia and Value added (current US$) of Uruguay?
Your answer should be compact. 4.32e+1. In the year 2000, what is the difference between the Value added (current US$) in Kazakhstan and Value added (current US$) in Oman?
Your response must be concise. 1.15e+09. In the year 2000, what is the difference between the Value added (current US$) of Kazakhstan and Value added (current US$) of Uruguay?
Make the answer very short. -5.25e+09. In the year 2000, what is the difference between the Value added (current US$) of Oman and Value added (current US$) of Uruguay?
Offer a very short reply. -6.41e+09. In the year 2001, what is the difference between the Value added (current US$) of Colombia and Value added (current US$) of Kazakhstan?
Your answer should be very brief. 4.55e+1. In the year 2001, what is the difference between the Value added (current US$) in Colombia and Value added (current US$) in Oman?
Your answer should be very brief. 4.81e+1. In the year 2001, what is the difference between the Value added (current US$) in Colombia and Value added (current US$) in Uruguay?
Offer a very short reply. 4.34e+1. In the year 2001, what is the difference between the Value added (current US$) in Kazakhstan and Value added (current US$) in Oman?
Provide a succinct answer. 2.66e+09. In the year 2001, what is the difference between the Value added (current US$) of Kazakhstan and Value added (current US$) of Uruguay?
Ensure brevity in your answer.  -2.09e+09. In the year 2001, what is the difference between the Value added (current US$) in Oman and Value added (current US$) in Uruguay?
Your answer should be compact. -4.75e+09. What is the ratio of the Value added (current US$) of Colombia in 1995 to that in 1996?
Keep it short and to the point. 0.9. What is the ratio of the Value added (current US$) in Kazakhstan in 1995 to that in 1996?
Provide a short and direct response. 0.9. What is the ratio of the Value added (current US$) in Uruguay in 1995 to that in 1996?
Your answer should be compact. 0.93. What is the ratio of the Value added (current US$) in Colombia in 1995 to that in 1997?
Give a very brief answer. 0.81. What is the ratio of the Value added (current US$) of Kazakhstan in 1995 to that in 1997?
Your answer should be very brief. 0.84. What is the ratio of the Value added (current US$) of Oman in 1995 to that in 1997?
Give a very brief answer. 0.91. What is the ratio of the Value added (current US$) of Uruguay in 1995 to that in 1997?
Your response must be concise. 0.86. What is the ratio of the Value added (current US$) of Colombia in 1995 to that in 1998?
Offer a terse response. 0.86. What is the ratio of the Value added (current US$) in Kazakhstan in 1995 to that in 1998?
Give a very brief answer. 0.87. What is the ratio of the Value added (current US$) in Oman in 1995 to that in 1998?
Your answer should be compact. 0.88. What is the ratio of the Value added (current US$) in Uruguay in 1995 to that in 1998?
Offer a terse response. 0.82. What is the ratio of the Value added (current US$) of Colombia in 1995 to that in 1999?
Provide a short and direct response. 0.98. What is the ratio of the Value added (current US$) of Kazakhstan in 1995 to that in 1999?
Give a very brief answer. 1.25. What is the ratio of the Value added (current US$) in Oman in 1995 to that in 1999?
Your answer should be very brief. 0.89. What is the ratio of the Value added (current US$) in Uruguay in 1995 to that in 1999?
Provide a short and direct response. 0.84. What is the ratio of the Value added (current US$) in Colombia in 1995 to that in 2000?
Provide a succinct answer. 0.79. What is the ratio of the Value added (current US$) in Kazakhstan in 1995 to that in 2000?
Keep it short and to the point. 1.25. What is the ratio of the Value added (current US$) in Oman in 1995 to that in 2000?
Your response must be concise. 0.93. What is the ratio of the Value added (current US$) in Uruguay in 1995 to that in 2000?
Keep it short and to the point. 0.86. What is the ratio of the Value added (current US$) in Colombia in 1995 to that in 2001?
Make the answer very short. 0.8. What is the ratio of the Value added (current US$) in Kazakhstan in 1995 to that in 2001?
Give a very brief answer. 1.02. What is the ratio of the Value added (current US$) in Oman in 1995 to that in 2001?
Your answer should be compact. 0.87. What is the ratio of the Value added (current US$) in Uruguay in 1995 to that in 2001?
Ensure brevity in your answer.  0.94. What is the ratio of the Value added (current US$) in Colombia in 1996 to that in 1997?
Provide a short and direct response. 0.89. What is the ratio of the Value added (current US$) in Kazakhstan in 1996 to that in 1997?
Provide a short and direct response. 0.93. What is the ratio of the Value added (current US$) of Oman in 1996 to that in 1997?
Provide a succinct answer. 0.95. What is the ratio of the Value added (current US$) of Uruguay in 1996 to that in 1997?
Offer a terse response. 0.93. What is the ratio of the Value added (current US$) of Colombia in 1996 to that in 1998?
Offer a very short reply. 0.95. What is the ratio of the Value added (current US$) of Kazakhstan in 1996 to that in 1998?
Provide a succinct answer. 0.97. What is the ratio of the Value added (current US$) of Oman in 1996 to that in 1998?
Offer a terse response. 0.93. What is the ratio of the Value added (current US$) of Uruguay in 1996 to that in 1998?
Offer a very short reply. 0.88. What is the ratio of the Value added (current US$) of Colombia in 1996 to that in 1999?
Ensure brevity in your answer.  1.08. What is the ratio of the Value added (current US$) in Kazakhstan in 1996 to that in 1999?
Keep it short and to the point. 1.39. What is the ratio of the Value added (current US$) in Oman in 1996 to that in 1999?
Your answer should be very brief. 0.93. What is the ratio of the Value added (current US$) in Uruguay in 1996 to that in 1999?
Ensure brevity in your answer.  0.91. What is the ratio of the Value added (current US$) of Colombia in 1996 to that in 2000?
Keep it short and to the point. 0.87. What is the ratio of the Value added (current US$) of Kazakhstan in 1996 to that in 2000?
Offer a very short reply. 1.39. What is the ratio of the Value added (current US$) in Oman in 1996 to that in 2000?
Keep it short and to the point. 0.98. What is the ratio of the Value added (current US$) in Uruguay in 1996 to that in 2000?
Provide a succinct answer. 0.93. What is the ratio of the Value added (current US$) in Colombia in 1996 to that in 2001?
Provide a short and direct response. 0.89. What is the ratio of the Value added (current US$) of Kazakhstan in 1996 to that in 2001?
Give a very brief answer. 1.13. What is the ratio of the Value added (current US$) in Oman in 1996 to that in 2001?
Provide a succinct answer. 0.92. What is the ratio of the Value added (current US$) in Uruguay in 1996 to that in 2001?
Make the answer very short. 1.02. What is the ratio of the Value added (current US$) in Colombia in 1997 to that in 1998?
Make the answer very short. 1.07. What is the ratio of the Value added (current US$) of Kazakhstan in 1997 to that in 1998?
Your answer should be compact. 1.04. What is the ratio of the Value added (current US$) in Oman in 1997 to that in 1998?
Offer a terse response. 0.97. What is the ratio of the Value added (current US$) of Uruguay in 1997 to that in 1998?
Keep it short and to the point. 0.95. What is the ratio of the Value added (current US$) in Colombia in 1997 to that in 1999?
Your answer should be very brief. 1.21. What is the ratio of the Value added (current US$) of Kazakhstan in 1997 to that in 1999?
Give a very brief answer. 1.49. What is the ratio of the Value added (current US$) in Oman in 1997 to that in 1999?
Offer a terse response. 0.98. What is the ratio of the Value added (current US$) in Uruguay in 1997 to that in 1999?
Keep it short and to the point. 0.97. What is the ratio of the Value added (current US$) in Colombia in 1997 to that in 2000?
Make the answer very short. 0.98. What is the ratio of the Value added (current US$) of Kazakhstan in 1997 to that in 2000?
Your response must be concise. 1.49. What is the ratio of the Value added (current US$) in Oman in 1997 to that in 2000?
Your answer should be compact. 1.03. What is the ratio of the Value added (current US$) of Uruguay in 1997 to that in 2000?
Give a very brief answer. 1. What is the ratio of the Value added (current US$) of Colombia in 1997 to that in 2001?
Provide a short and direct response. 0.99. What is the ratio of the Value added (current US$) of Kazakhstan in 1997 to that in 2001?
Give a very brief answer. 1.21. What is the ratio of the Value added (current US$) in Uruguay in 1997 to that in 2001?
Your answer should be very brief. 1.09. What is the ratio of the Value added (current US$) in Colombia in 1998 to that in 1999?
Provide a succinct answer. 1.14. What is the ratio of the Value added (current US$) in Kazakhstan in 1998 to that in 1999?
Offer a very short reply. 1.43. What is the ratio of the Value added (current US$) of Oman in 1998 to that in 1999?
Provide a short and direct response. 1.01. What is the ratio of the Value added (current US$) of Uruguay in 1998 to that in 1999?
Offer a terse response. 1.03. What is the ratio of the Value added (current US$) in Colombia in 1998 to that in 2000?
Your response must be concise. 0.92. What is the ratio of the Value added (current US$) of Kazakhstan in 1998 to that in 2000?
Keep it short and to the point. 1.43. What is the ratio of the Value added (current US$) in Oman in 1998 to that in 2000?
Your answer should be very brief. 1.05. What is the ratio of the Value added (current US$) in Uruguay in 1998 to that in 2000?
Provide a short and direct response. 1.06. What is the ratio of the Value added (current US$) in Colombia in 1998 to that in 2001?
Your answer should be very brief. 0.93. What is the ratio of the Value added (current US$) in Kazakhstan in 1998 to that in 2001?
Ensure brevity in your answer.  1.16. What is the ratio of the Value added (current US$) in Oman in 1998 to that in 2001?
Give a very brief answer. 0.99. What is the ratio of the Value added (current US$) in Uruguay in 1998 to that in 2001?
Your answer should be very brief. 1.16. What is the ratio of the Value added (current US$) in Colombia in 1999 to that in 2000?
Offer a terse response. 0.81. What is the ratio of the Value added (current US$) in Oman in 1999 to that in 2000?
Provide a succinct answer. 1.04. What is the ratio of the Value added (current US$) in Uruguay in 1999 to that in 2000?
Make the answer very short. 1.03. What is the ratio of the Value added (current US$) in Colombia in 1999 to that in 2001?
Your answer should be very brief. 0.82. What is the ratio of the Value added (current US$) of Kazakhstan in 1999 to that in 2001?
Your answer should be very brief. 0.81. What is the ratio of the Value added (current US$) in Oman in 1999 to that in 2001?
Offer a terse response. 0.98. What is the ratio of the Value added (current US$) in Uruguay in 1999 to that in 2001?
Your answer should be very brief. 1.12. What is the ratio of the Value added (current US$) of Colombia in 2000 to that in 2001?
Provide a short and direct response. 1.02. What is the ratio of the Value added (current US$) of Kazakhstan in 2000 to that in 2001?
Your answer should be very brief. 0.81. What is the ratio of the Value added (current US$) of Oman in 2000 to that in 2001?
Ensure brevity in your answer.  0.94. What is the ratio of the Value added (current US$) in Uruguay in 2000 to that in 2001?
Your answer should be very brief. 1.09. What is the difference between the highest and the second highest Value added (current US$) of Colombia?
Offer a terse response. 9.92e+08. What is the difference between the highest and the second highest Value added (current US$) in Kazakhstan?
Keep it short and to the point. 5.16e+08. What is the difference between the highest and the second highest Value added (current US$) in Oman?
Keep it short and to the point. 8.65e+07. What is the difference between the highest and the second highest Value added (current US$) of Uruguay?
Make the answer very short. 3.91e+08. What is the difference between the highest and the lowest Value added (current US$) in Colombia?
Your response must be concise. 1.21e+1. What is the difference between the highest and the lowest Value added (current US$) of Kazakhstan?
Keep it short and to the point. 4.26e+09. What is the difference between the highest and the lowest Value added (current US$) in Oman?
Provide a short and direct response. 1.02e+09. What is the difference between the highest and the lowest Value added (current US$) in Uruguay?
Provide a short and direct response. 2.70e+09. 